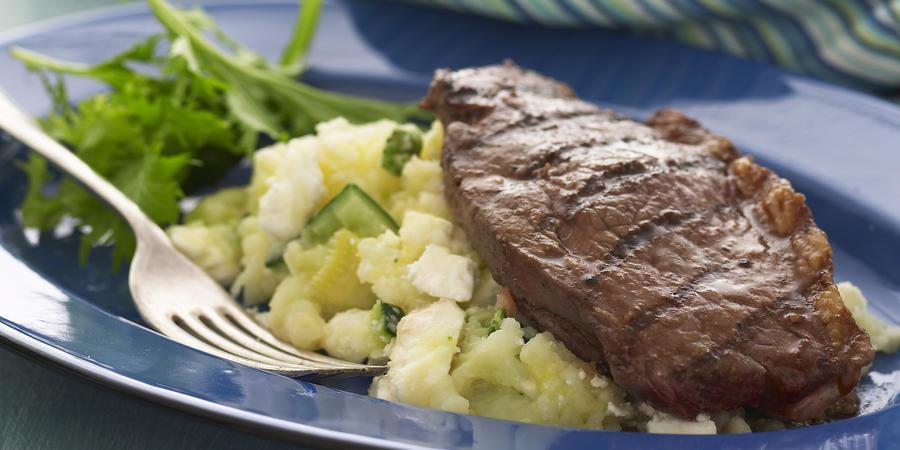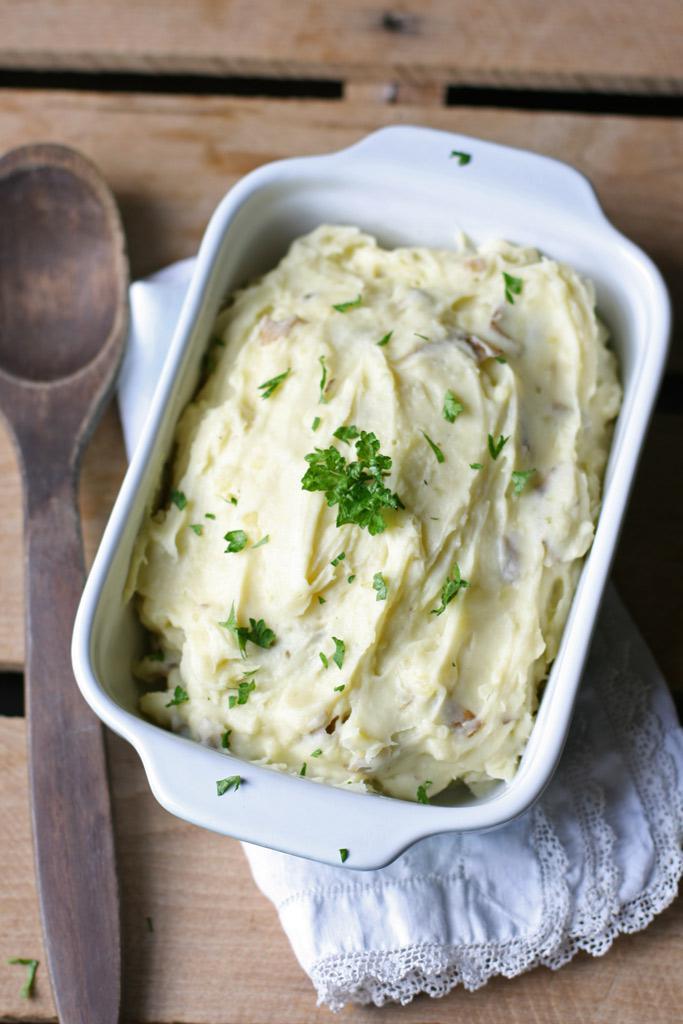The first image is the image on the left, the second image is the image on the right. For the images shown, is this caption "One piece of silverware is in a dish that contains something resembling mashed potatoes." true? Answer yes or no. Yes. 